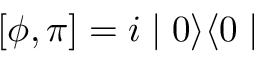<formula> <loc_0><loc_0><loc_500><loc_500>[ \phi , \pi ] = i | 0 \rangle \langle 0 |</formula> 